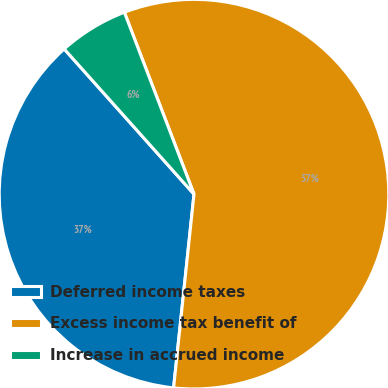Convert chart. <chart><loc_0><loc_0><loc_500><loc_500><pie_chart><fcel>Deferred income taxes<fcel>Excess income tax benefit of<fcel>Increase in accrued income<nl><fcel>36.72%<fcel>57.49%<fcel>5.79%<nl></chart> 